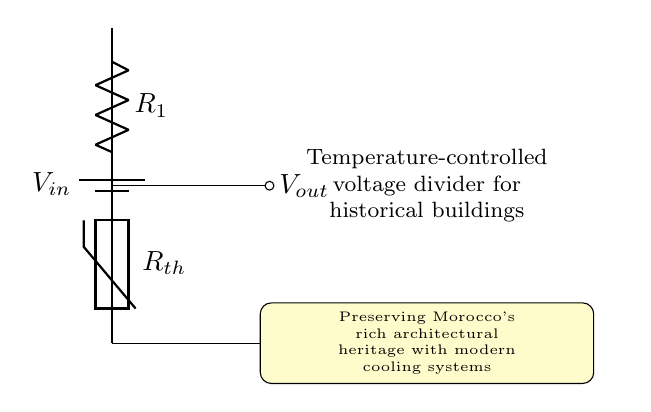What is the input voltage of this circuit? The input voltage is represented by \( V_{in} \) at the top of the circuit diagram, indicating the supply voltage for the voltage divider.
Answer: \( V_{in} \) What type of resistor is used in this circuit? The circuit diagram indicates that a thermistor is used, as denoted by \( R_{th} \) in the diagram. A thermistor is a temperature-dependent resistor.
Answer: Thermistor What components are in series in this circuit? The components \( R_1 \) (resistor) and \( R_{th} \) (thermistor) are connected in series, meaning the current flows through both components sequentially.
Answer: Resistor and Thermistor What is the output voltage in the voltage divider? The output voltage is denoted by \( V_{out} \), which is taken from the junction between \( R_1 \) and the thermistor \( R_{th} \).
Answer: \( V_{out} \) How does temperature affect the output voltage? As the temperature changes, the resistance of the thermistor \( R_{th} \) changes accordingly. This change in resistance affects the voltage drop across \( R_{th} \), thus altering \( V_{out} \).
Answer: Variably What is the purpose of this voltage divider circuit? The primary function of this voltage divider is to regulate the cooling system by adjusting the output voltage based on temperature changes, thereby maintaining conditions suitable for preserving historical buildings.
Answer: Temperature control 